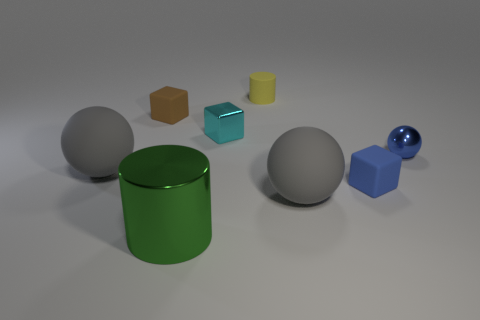Are any small blue cylinders visible?
Offer a terse response. No. There is a thing that is behind the tiny cyan block and on the right side of the small brown object; what is its color?
Make the answer very short. Yellow. There is a gray matte object that is on the right side of the tiny brown matte block; is its size the same as the cube to the right of the tiny cylinder?
Provide a succinct answer. No. What number of other things are the same size as the yellow rubber thing?
Offer a very short reply. 4. What number of cylinders are in front of the small blue metallic object that is in front of the small brown thing?
Your answer should be very brief. 1. Are there fewer small shiny spheres that are behind the tiny blue block than metal blocks?
Provide a short and direct response. No. What is the shape of the large rubber thing that is on the left side of the metal thing that is in front of the big sphere that is right of the tiny cyan metallic thing?
Provide a short and direct response. Sphere. Does the tiny blue matte thing have the same shape as the small brown matte thing?
Provide a succinct answer. Yes. What number of other objects are the same shape as the cyan thing?
Provide a succinct answer. 2. What color is the shiny thing that is the same size as the blue ball?
Provide a succinct answer. Cyan. 